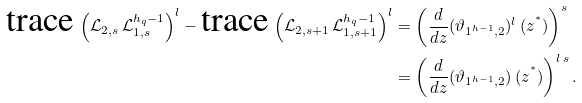<formula> <loc_0><loc_0><loc_500><loc_500>\text {trace} \, \left ( \mathcal { L } _ { 2 , s } \, \mathcal { L } _ { 1 , s } ^ { h _ { q } - 1 } \right ) ^ { l } - \text {trace} \, \left ( \mathcal { L } _ { 2 , s + 1 } \, \mathcal { L } _ { 1 , s + 1 } ^ { h _ { q } - 1 } \right ) ^ { l } & = \left ( \frac { d } { d z } ( \vartheta _ { 1 ^ { h - 1 } , 2 } ) ^ { l } \, ( z ^ { ^ { * } } ) \right ) ^ { s } \\ & = \left ( \frac { d } { d z } ( \vartheta _ { 1 ^ { h - 1 } , 2 } ) \, ( z ^ { ^ { * } } ) \right ) ^ { l \, s } .</formula> 